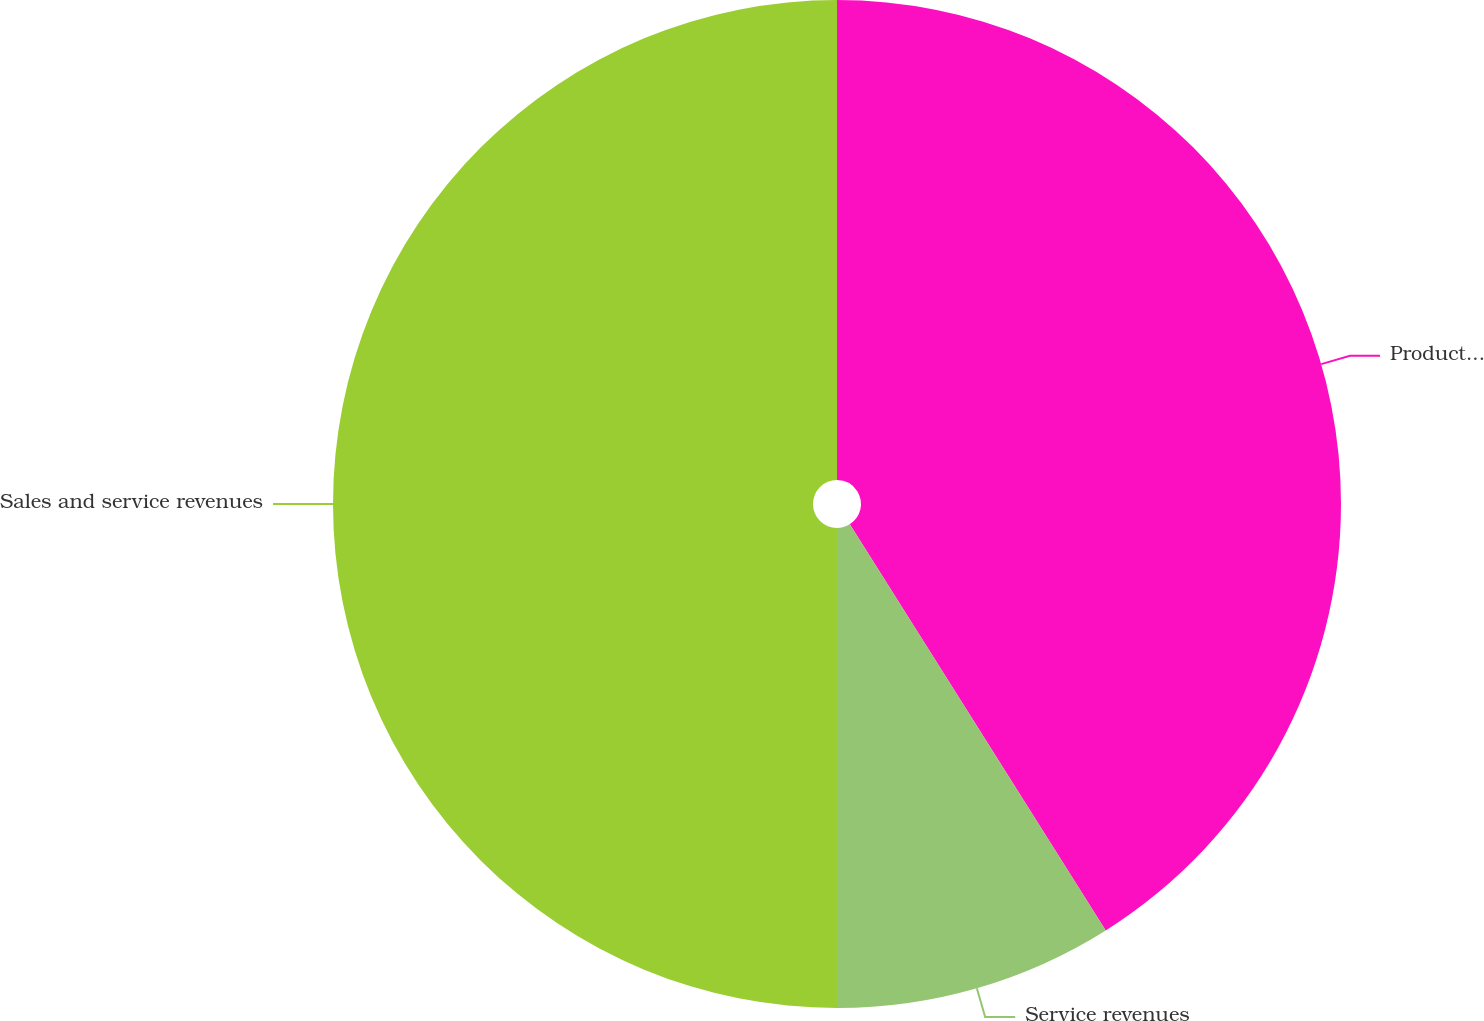<chart> <loc_0><loc_0><loc_500><loc_500><pie_chart><fcel>Product sales<fcel>Service revenues<fcel>Sales and service revenues<nl><fcel>41.05%<fcel>8.95%<fcel>50.0%<nl></chart> 